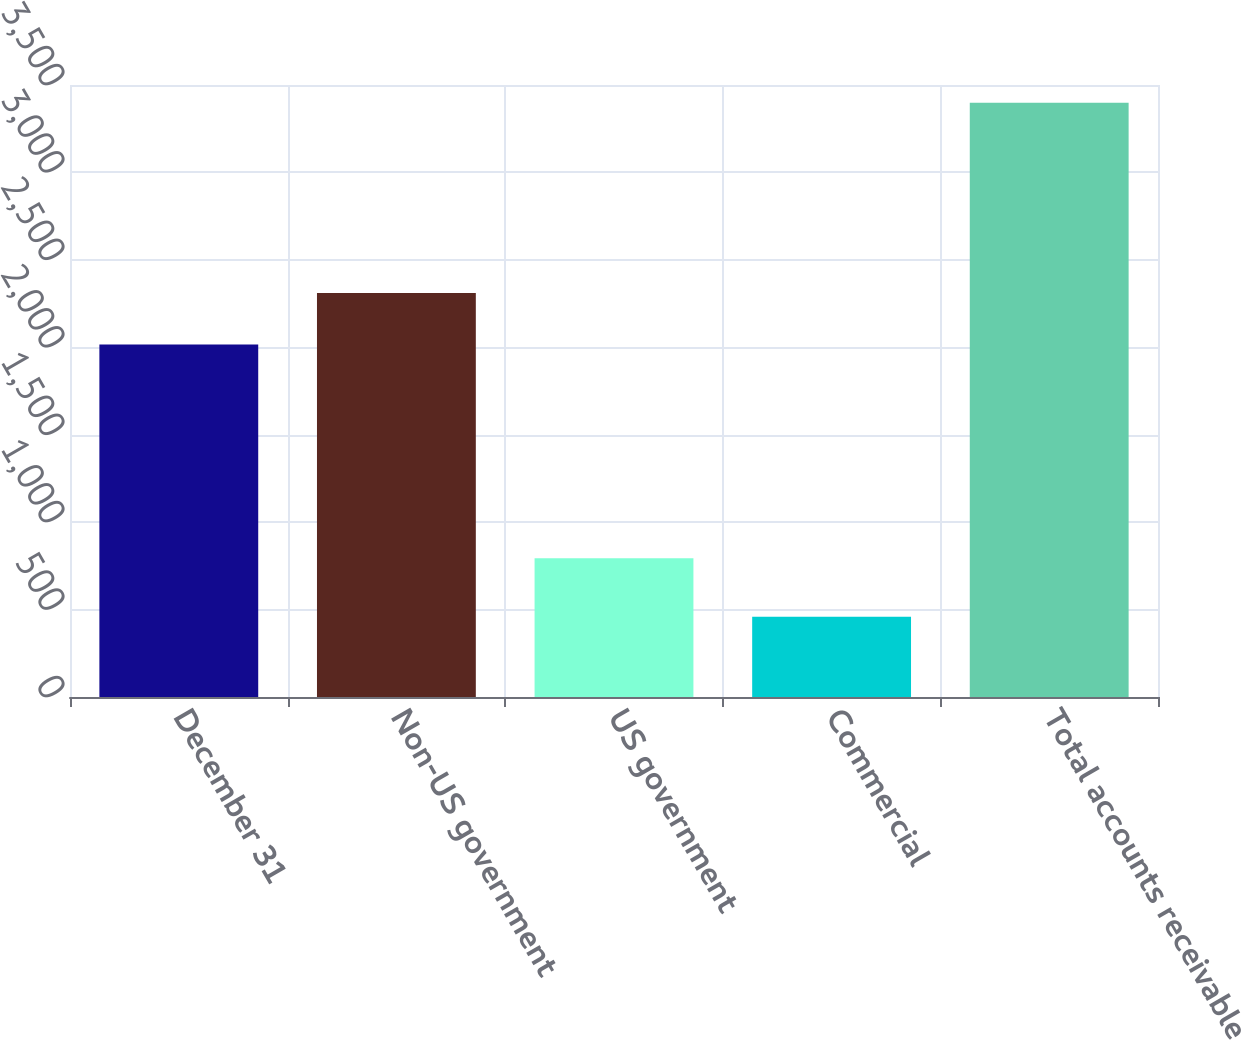<chart> <loc_0><loc_0><loc_500><loc_500><bar_chart><fcel>December 31<fcel>Non-US government<fcel>US government<fcel>Commercial<fcel>Total accounts receivable<nl><fcel>2016<fcel>2310<fcel>793<fcel>459<fcel>3399<nl></chart> 